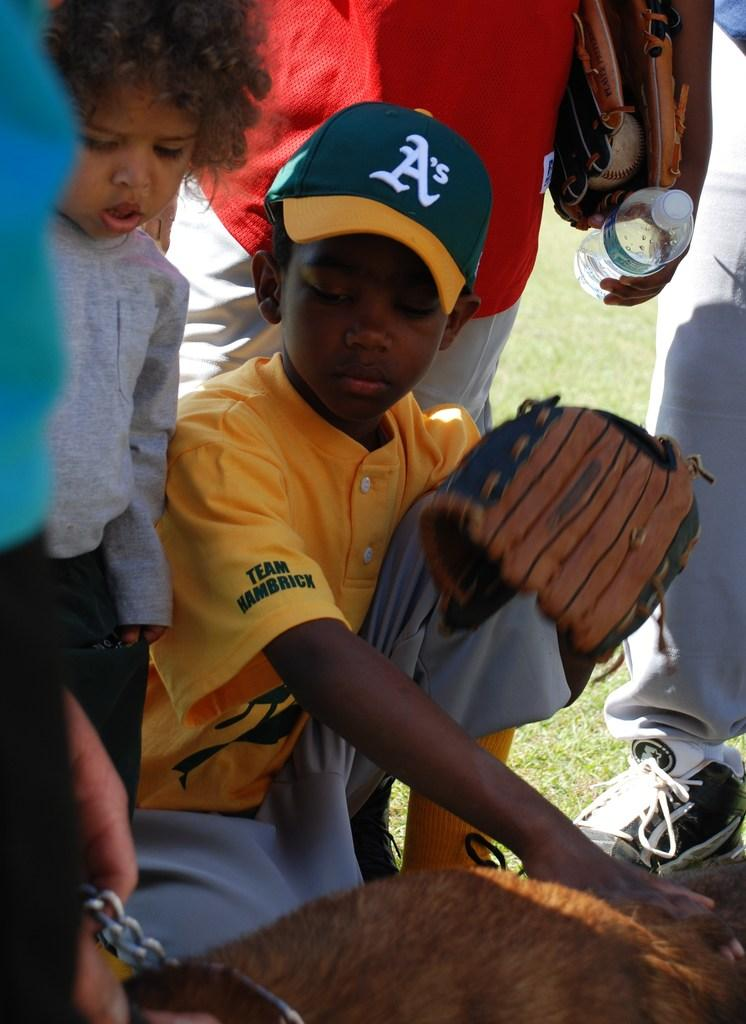<image>
Relay a brief, clear account of the picture shown. Boy looking at something while wearing a cap with the letter A. 